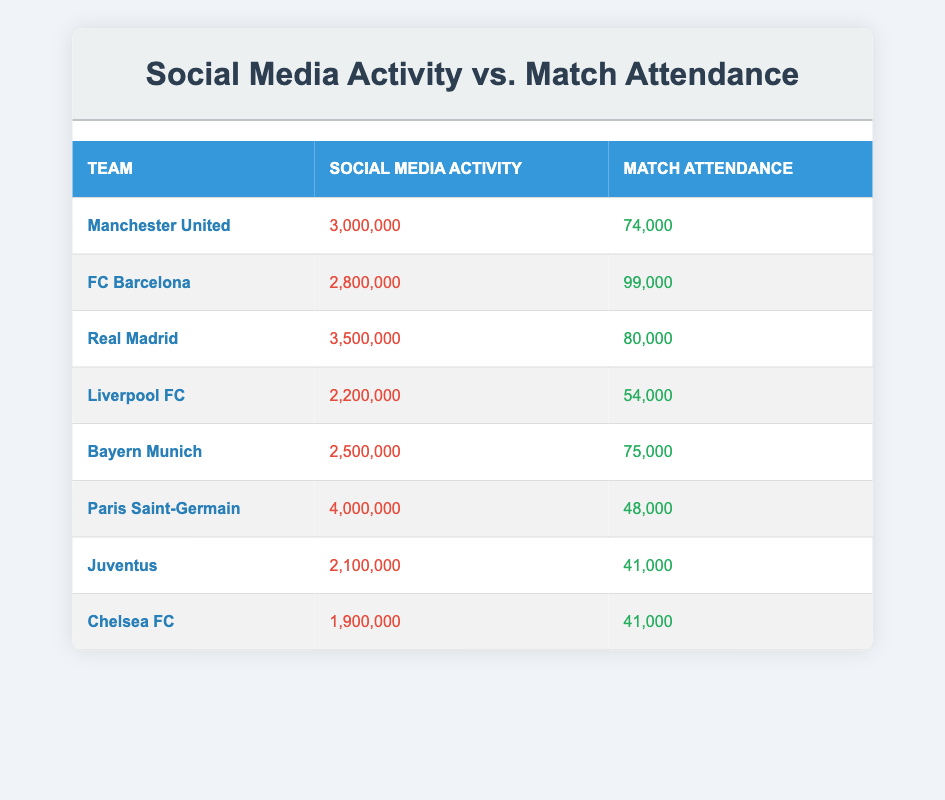What is the social media activity of FC Barcelona? The table directly lists the social media activity for each team. For FC Barcelona, it states that their social media activity is 2,800,000.
Answer: 2,800,000 Which team has the highest match attendance? The match attendance for each team is provided in the table. By comparing the values, I see that FC Barcelona has the highest match attendance at 99,000.
Answer: 99,000 What is the average match attendance for the teams listed? To find the average, add the match attendance values: (74,000 + 99,000 + 80,000 + 54,000 + 75,000 + 48,000 + 41,000 + 41,000) = 512,000. Then, divide by the number of teams (8) to get 512,000 / 8 = 64,000.
Answer: 64,000 Does Paris Saint-Germain have more social media activity than Liverpool FC? By comparing the two specific social media activity values, I find that Paris Saint-Germain has 4,000,000 while Liverpool FC has 2,200,000. Hence, PSG does have more social media activity.
Answer: Yes What is the difference in social media activity between Manchester United and Juventus? The two social media activity values are 3,000,000 for Manchester United and 2,100,000 for Juventus. The difference is calculated as 3,000,000 - 2,100,000 = 900,000.
Answer: 900,000 Which team has the lowest match attendance? The attendance values for each team are compared, and I can see that both Chelsea FC and Juventus have the lowest attendance, which is 41,000.
Answer: 41,000 Is there a correlation between social media activity and match attendance for the teams listed? While the table does not explicitly state correlation, I can analyze the social media activity and match attendance. For example, despite having the highest social media activity (4,000,000), Paris Saint-Germain has low attendance (48,000), indicating a lack of correlation between the two metrics.
Answer: No What team has the most social media activity among all the teams? The table lists the social media activity values, and by comparing, I see that Real Madrid has the highest with 3,500,000.
Answer: Real Madrid 